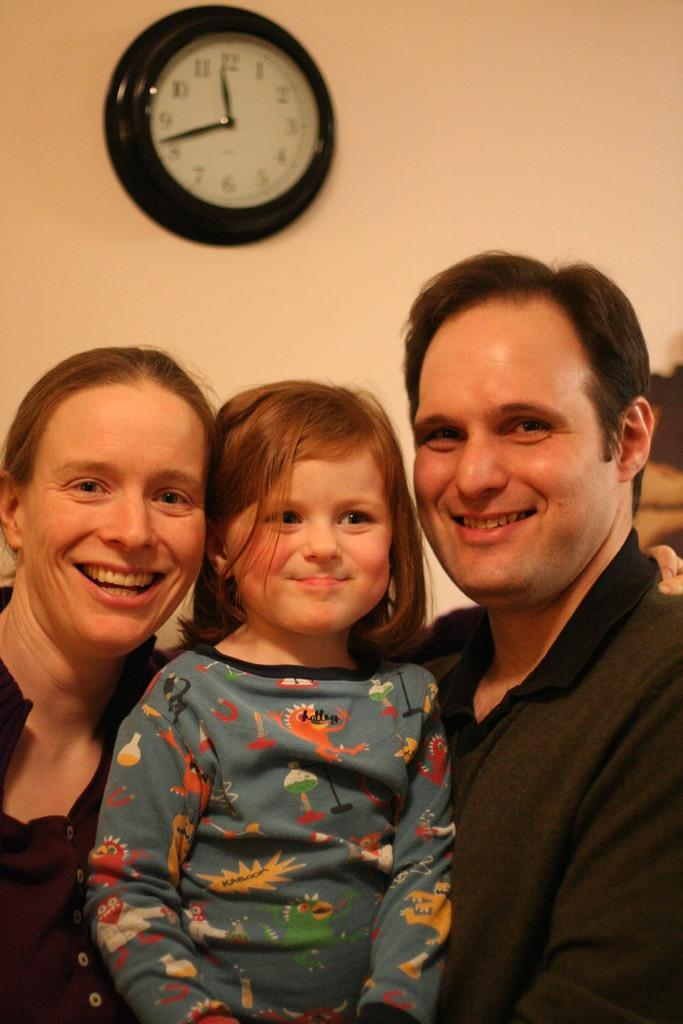Who or what is present in the image? There are people in the image. Can you describe any objects or features in the background of the image? There is a clock on the wall in the background of the image. What type of nerve can be seen in the image? There is no nerve present in the image; it features people and a clock on the wall. 